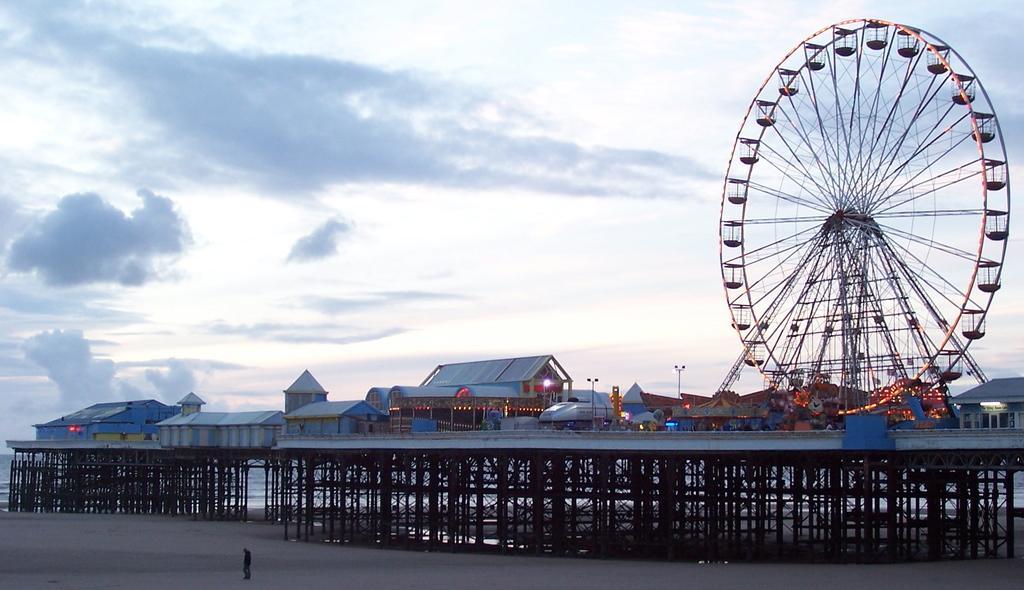Could you give a brief overview of what you see in this image? In this image, I can see a Ferris wheel, buildings, lights, light poles and iron pillars. At the bottom of the image, I can see a person standing. In the background, there is water and the sky. 